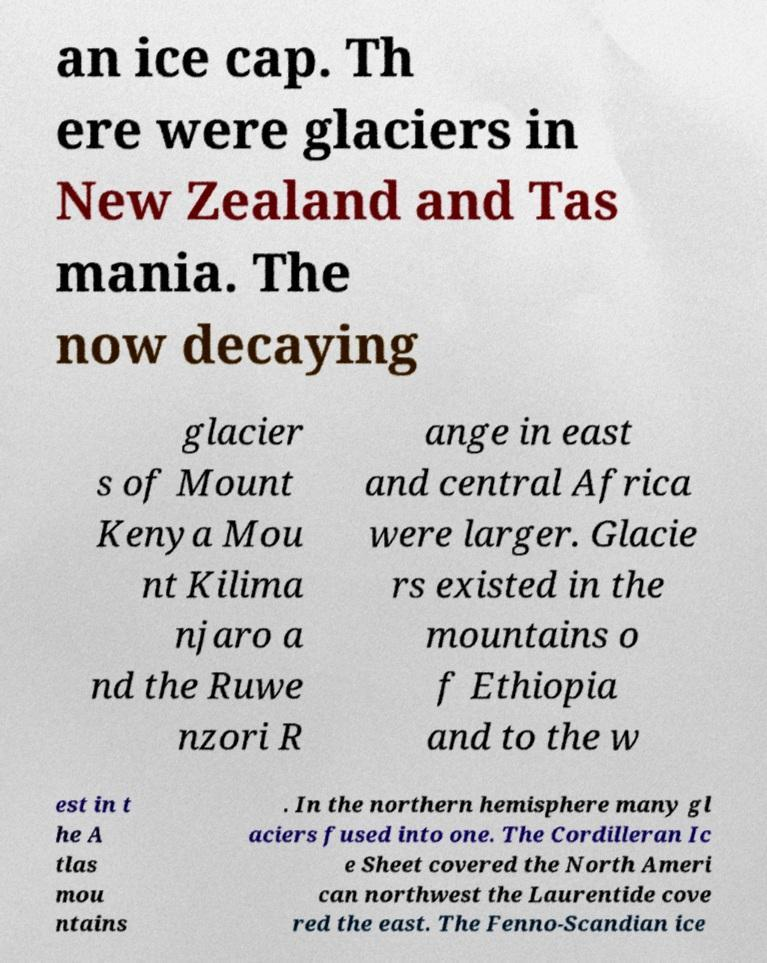Please read and relay the text visible in this image. What does it say? an ice cap. Th ere were glaciers in New Zealand and Tas mania. The now decaying glacier s of Mount Kenya Mou nt Kilima njaro a nd the Ruwe nzori R ange in east and central Africa were larger. Glacie rs existed in the mountains o f Ethiopia and to the w est in t he A tlas mou ntains . In the northern hemisphere many gl aciers fused into one. The Cordilleran Ic e Sheet covered the North Ameri can northwest the Laurentide cove red the east. The Fenno-Scandian ice 